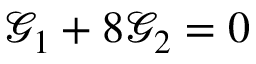<formula> <loc_0><loc_0><loc_500><loc_500>\mathcal { G } _ { 1 } + 8 \mathcal { G } _ { 2 } = 0</formula> 